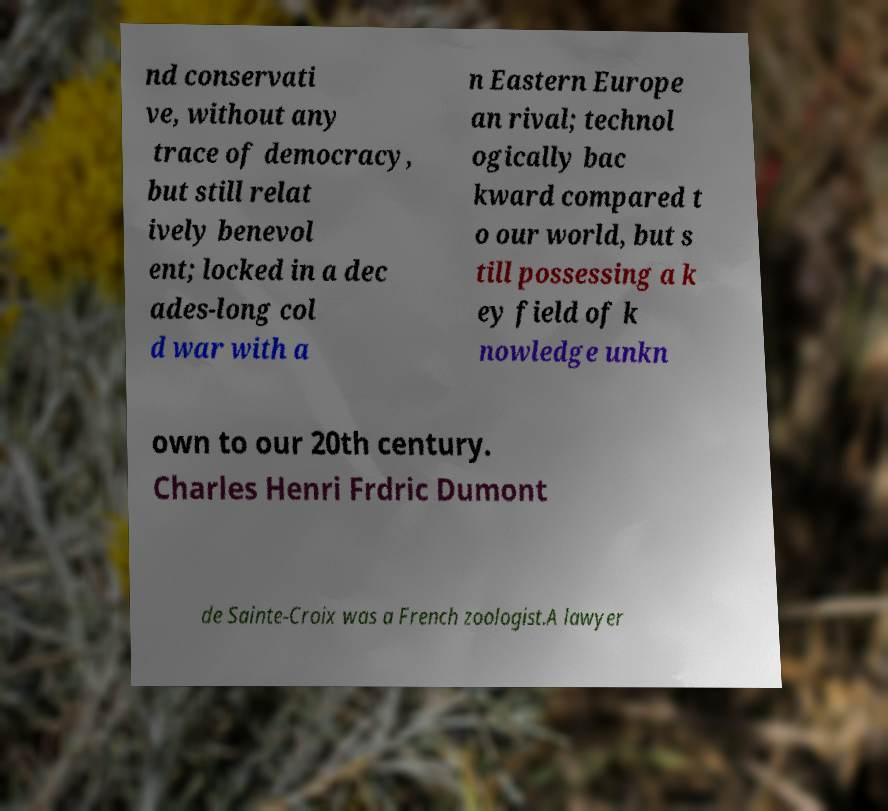Please read and relay the text visible in this image. What does it say? nd conservati ve, without any trace of democracy, but still relat ively benevol ent; locked in a dec ades-long col d war with a n Eastern Europe an rival; technol ogically bac kward compared t o our world, but s till possessing a k ey field of k nowledge unkn own to our 20th century. Charles Henri Frdric Dumont de Sainte-Croix was a French zoologist.A lawyer 